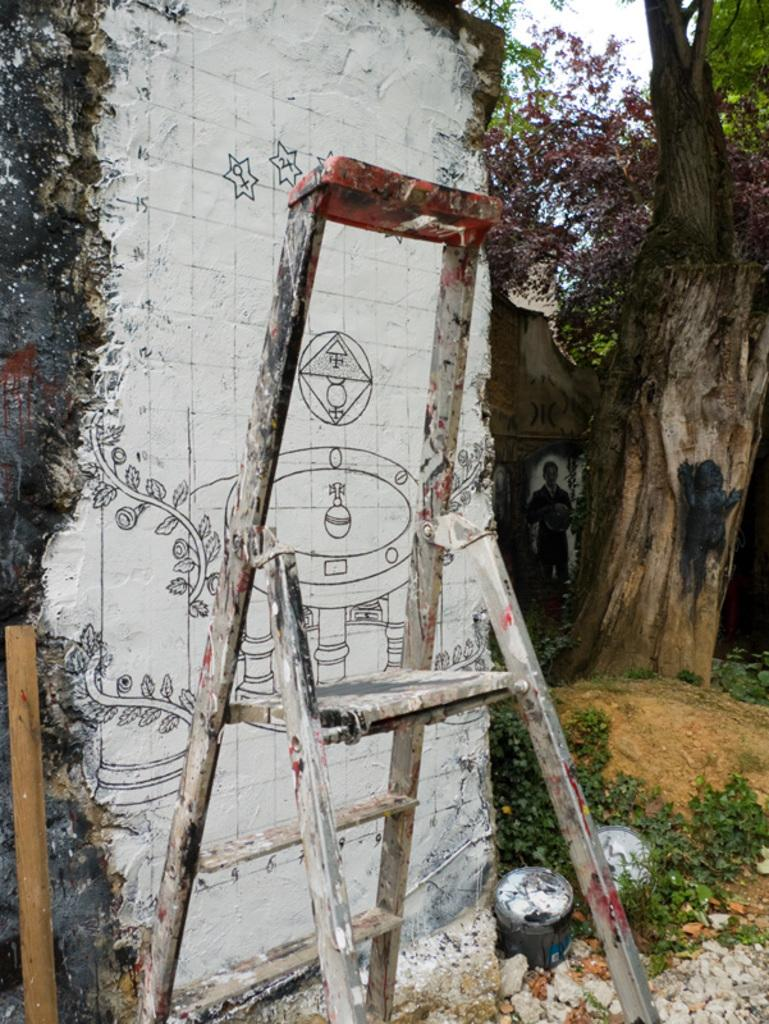What object can be seen in the image that is used for climbing? There is a ladder in the image. What is located behind the ladder in the image? There is a wall in the background of the image. What is on the wall in the image? There is a painting on the wall. What type of natural environment is visible in the background of the image? Trees are visible in the background of the image. What part of the natural environment is visible in the image? The sky is visible in the image. What type of test can be seen being conducted on the ladder in the image? There is no test being conducted on the ladder in the image; it is simply an object used for climbing. 